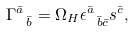<formula> <loc_0><loc_0><loc_500><loc_500>\Gamma ^ { \bar { a } } _ { \ \bar { b } } = \Omega _ { H } \epsilon ^ { \bar { a } } _ { \ \bar { b } \bar { c } } s ^ { \bar { c } } ,</formula> 